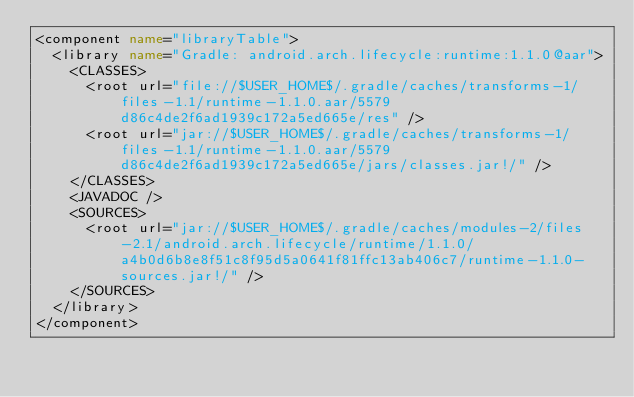Convert code to text. <code><loc_0><loc_0><loc_500><loc_500><_XML_><component name="libraryTable">
  <library name="Gradle: android.arch.lifecycle:runtime:1.1.0@aar">
    <CLASSES>
      <root url="file://$USER_HOME$/.gradle/caches/transforms-1/files-1.1/runtime-1.1.0.aar/5579d86c4de2f6ad1939c172a5ed665e/res" />
      <root url="jar://$USER_HOME$/.gradle/caches/transforms-1/files-1.1/runtime-1.1.0.aar/5579d86c4de2f6ad1939c172a5ed665e/jars/classes.jar!/" />
    </CLASSES>
    <JAVADOC />
    <SOURCES>
      <root url="jar://$USER_HOME$/.gradle/caches/modules-2/files-2.1/android.arch.lifecycle/runtime/1.1.0/a4b0d6b8e8f51c8f95d5a0641f81ffc13ab406c7/runtime-1.1.0-sources.jar!/" />
    </SOURCES>
  </library>
</component></code> 